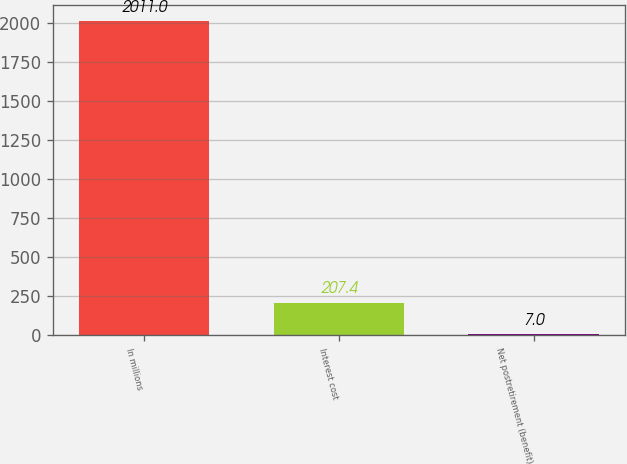Convert chart. <chart><loc_0><loc_0><loc_500><loc_500><bar_chart><fcel>In millions<fcel>Interest cost<fcel>Net postretirement (benefit)<nl><fcel>2011<fcel>207.4<fcel>7<nl></chart> 